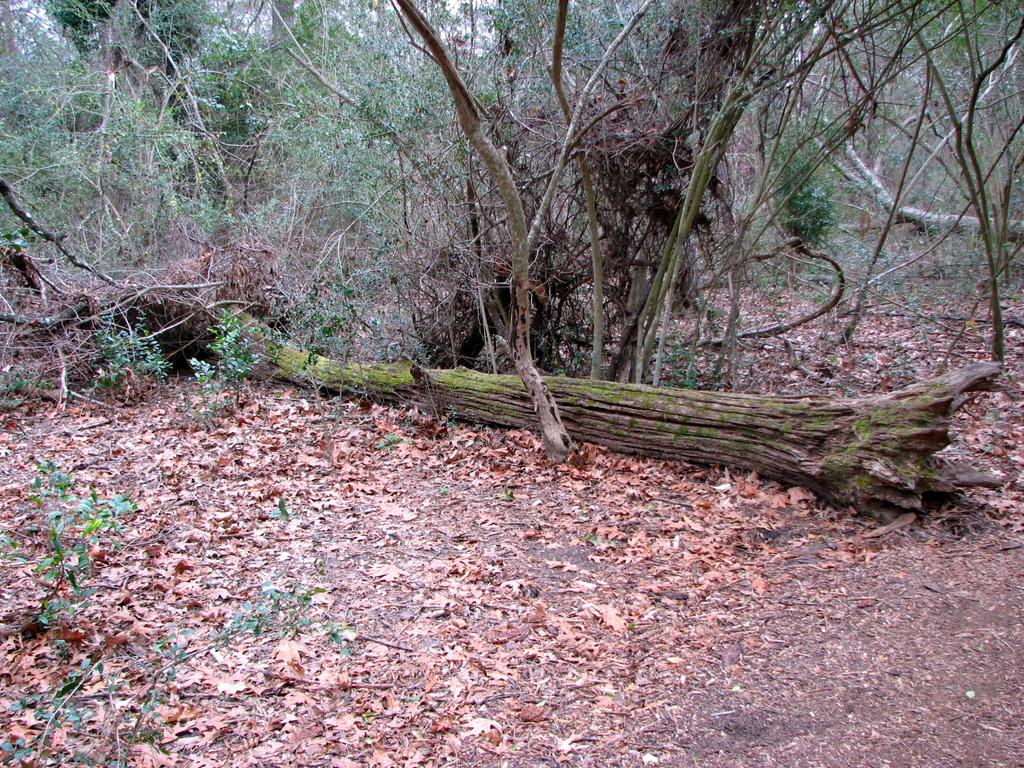What type of vegetation can be seen in the image? There are leaves, plants, and trees visible in the image. What part of a tree is lying on the floor in the image? There is a tree trunk on the floor in the image. Can you describe the trees in the image? The trees in the image have leaves and a visible trunk. What type of cushion is being used by the carpenter in the image? There is no carpenter or cushion present in the image. How does the tree in the image affect the mind of the viewer? The image does not provide any information about the viewer's mind or how the tree might affect it. 